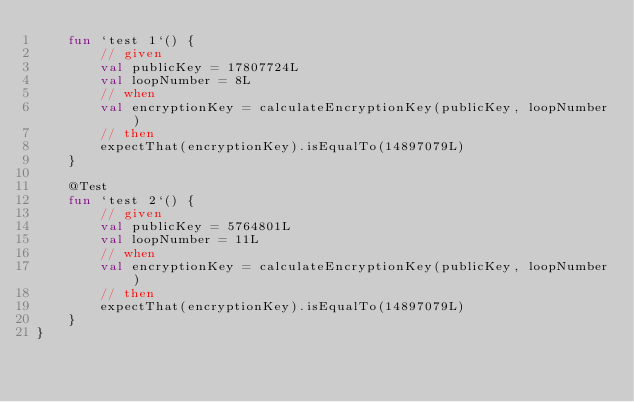<code> <loc_0><loc_0><loc_500><loc_500><_Kotlin_>    fun `test 1`() {
        // given
        val publicKey = 17807724L
        val loopNumber = 8L
        // when
        val encryptionKey = calculateEncryptionKey(publicKey, loopNumber)
        // then
        expectThat(encryptionKey).isEqualTo(14897079L)
    }

    @Test
    fun `test 2`() {
        // given
        val publicKey = 5764801L
        val loopNumber = 11L
        // when
        val encryptionKey = calculateEncryptionKey(publicKey, loopNumber)
        // then
        expectThat(encryptionKey).isEqualTo(14897079L)
    }
}</code> 